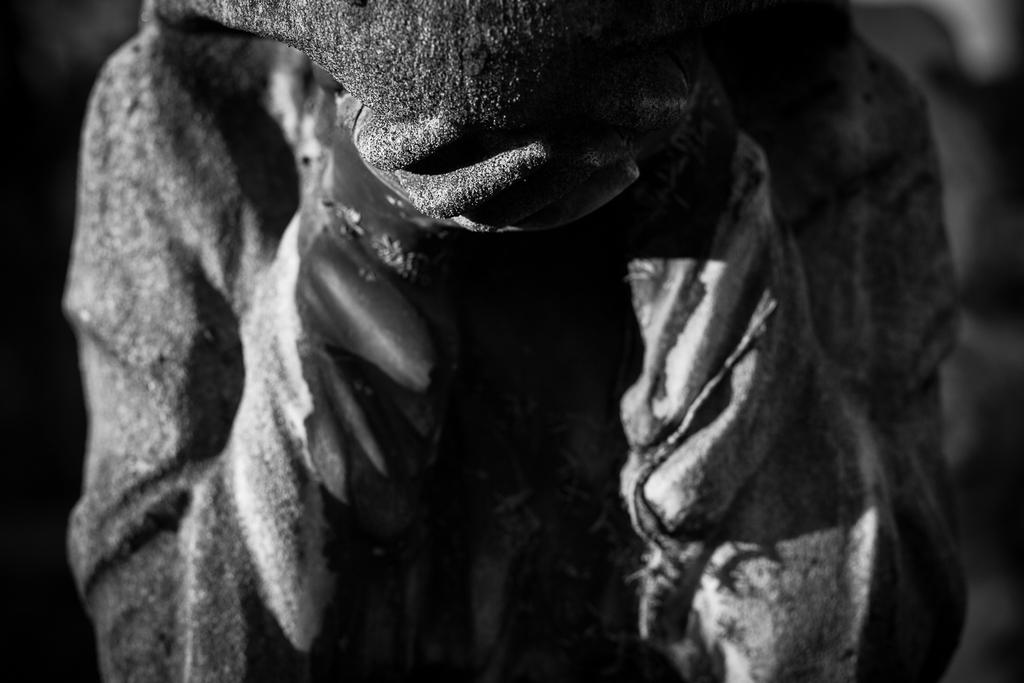What is the color scheme of the image? The image is in black and white. Can you describe the unspecified object or element in the image? Unfortunately, the provided facts do not offer any details about the unspecified object or element, referred to as "a thing." How does the cart fall in the image? There is no cart or any indication of falling in the image. What type of joke is being told by the object in the image? There is no object or any indication of a joke being told in the image. 